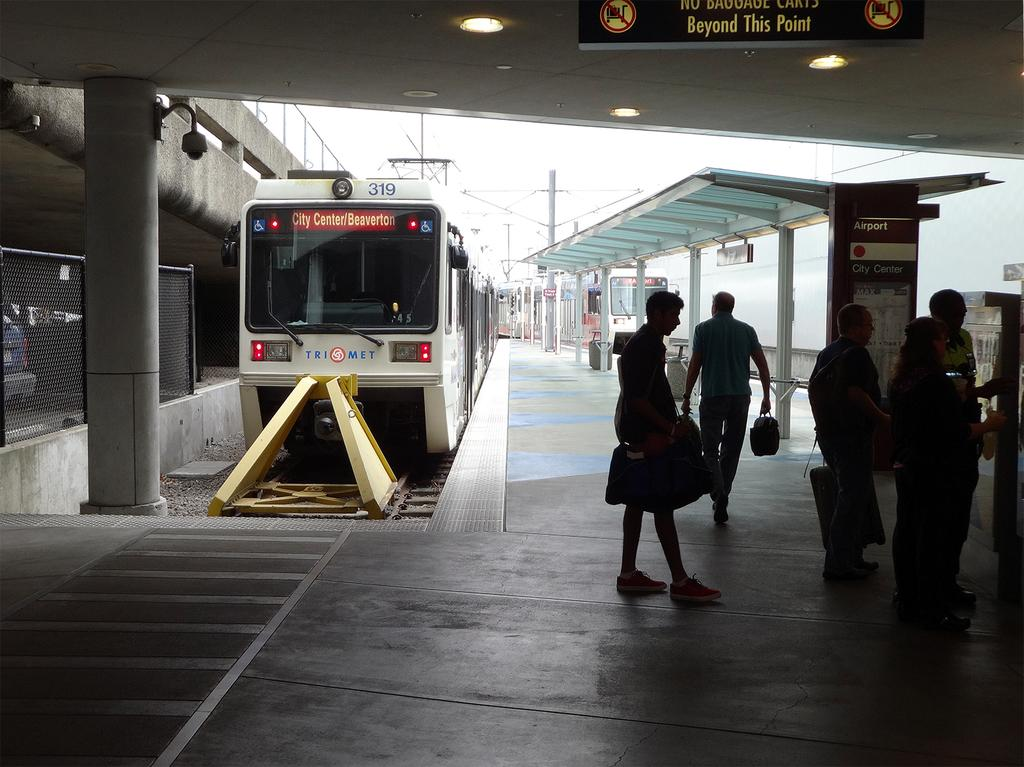<image>
Provide a brief description of the given image. bus number 319 heading to city center/beaverton at a bus stop 